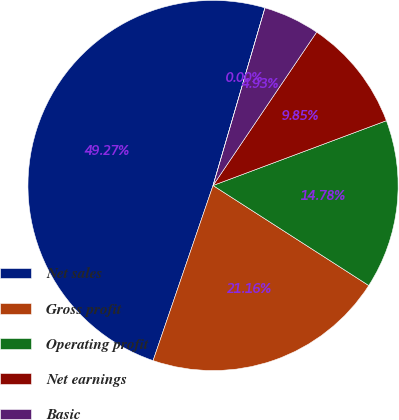Convert chart to OTSL. <chart><loc_0><loc_0><loc_500><loc_500><pie_chart><fcel>Net sales<fcel>Gross profit<fcel>Operating profit<fcel>Net earnings<fcel>Basic<fcel>Diluted<nl><fcel>49.27%<fcel>21.16%<fcel>14.78%<fcel>9.85%<fcel>4.93%<fcel>0.0%<nl></chart> 